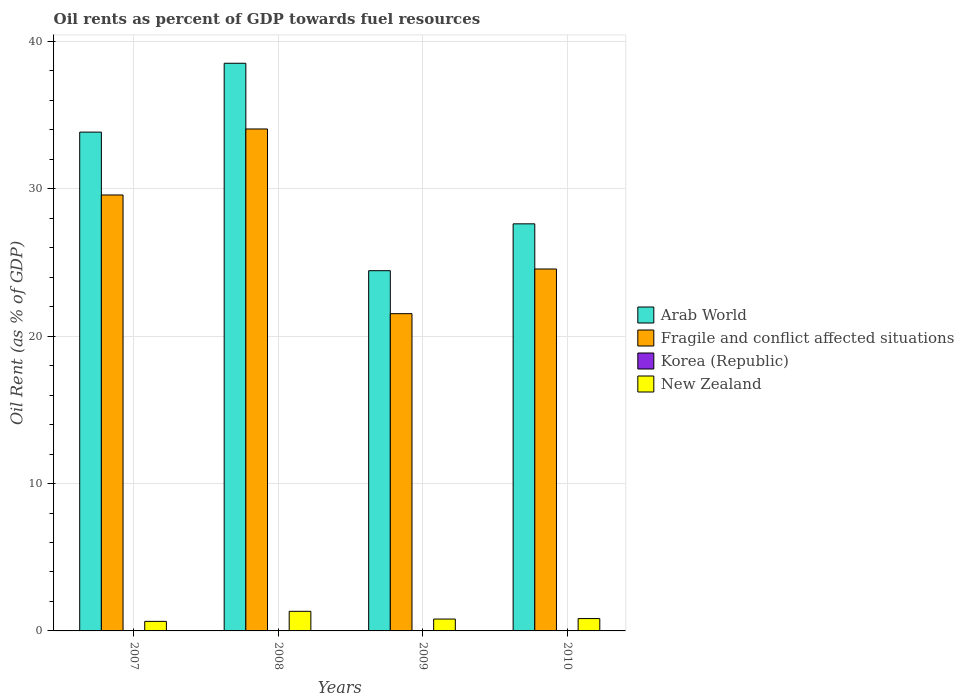How many different coloured bars are there?
Ensure brevity in your answer.  4. How many bars are there on the 1st tick from the left?
Offer a very short reply. 4. What is the label of the 1st group of bars from the left?
Ensure brevity in your answer.  2007. What is the oil rent in Korea (Republic) in 2009?
Give a very brief answer. 0. Across all years, what is the maximum oil rent in New Zealand?
Make the answer very short. 1.33. Across all years, what is the minimum oil rent in Arab World?
Keep it short and to the point. 24.44. In which year was the oil rent in Korea (Republic) maximum?
Offer a terse response. 2010. In which year was the oil rent in New Zealand minimum?
Make the answer very short. 2007. What is the total oil rent in Arab World in the graph?
Make the answer very short. 124.43. What is the difference between the oil rent in Arab World in 2008 and that in 2009?
Offer a terse response. 14.08. What is the difference between the oil rent in Korea (Republic) in 2008 and the oil rent in New Zealand in 2010?
Keep it short and to the point. -0.84. What is the average oil rent in Korea (Republic) per year?
Provide a short and direct response. 0. In the year 2009, what is the difference between the oil rent in Korea (Republic) and oil rent in New Zealand?
Ensure brevity in your answer.  -0.8. In how many years, is the oil rent in Korea (Republic) greater than 20 %?
Provide a succinct answer. 0. What is the ratio of the oil rent in Fragile and conflict affected situations in 2008 to that in 2010?
Provide a succinct answer. 1.39. What is the difference between the highest and the second highest oil rent in New Zealand?
Keep it short and to the point. 0.49. What is the difference between the highest and the lowest oil rent in Arab World?
Offer a very short reply. 14.08. Is the sum of the oil rent in Arab World in 2007 and 2009 greater than the maximum oil rent in New Zealand across all years?
Your answer should be very brief. Yes. Is it the case that in every year, the sum of the oil rent in Arab World and oil rent in Fragile and conflict affected situations is greater than the sum of oil rent in New Zealand and oil rent in Korea (Republic)?
Give a very brief answer. Yes. What does the 1st bar from the left in 2010 represents?
Your answer should be very brief. Arab World. What does the 1st bar from the right in 2009 represents?
Give a very brief answer. New Zealand. Is it the case that in every year, the sum of the oil rent in Korea (Republic) and oil rent in Arab World is greater than the oil rent in Fragile and conflict affected situations?
Provide a short and direct response. Yes. How many bars are there?
Give a very brief answer. 16. What is the difference between two consecutive major ticks on the Y-axis?
Provide a succinct answer. 10. Are the values on the major ticks of Y-axis written in scientific E-notation?
Provide a succinct answer. No. Does the graph contain any zero values?
Make the answer very short. No. Does the graph contain grids?
Provide a succinct answer. Yes. Where does the legend appear in the graph?
Your answer should be very brief. Center right. How are the legend labels stacked?
Give a very brief answer. Vertical. What is the title of the graph?
Offer a terse response. Oil rents as percent of GDP towards fuel resources. What is the label or title of the Y-axis?
Offer a very short reply. Oil Rent (as % of GDP). What is the Oil Rent (as % of GDP) in Arab World in 2007?
Give a very brief answer. 33.85. What is the Oil Rent (as % of GDP) of Fragile and conflict affected situations in 2007?
Keep it short and to the point. 29.58. What is the Oil Rent (as % of GDP) in Korea (Republic) in 2007?
Your answer should be compact. 0. What is the Oil Rent (as % of GDP) in New Zealand in 2007?
Offer a terse response. 0.65. What is the Oil Rent (as % of GDP) of Arab World in 2008?
Provide a succinct answer. 38.52. What is the Oil Rent (as % of GDP) in Fragile and conflict affected situations in 2008?
Your answer should be compact. 34.06. What is the Oil Rent (as % of GDP) in Korea (Republic) in 2008?
Offer a very short reply. 0. What is the Oil Rent (as % of GDP) in New Zealand in 2008?
Keep it short and to the point. 1.33. What is the Oil Rent (as % of GDP) in Arab World in 2009?
Ensure brevity in your answer.  24.44. What is the Oil Rent (as % of GDP) in Fragile and conflict affected situations in 2009?
Your answer should be compact. 21.53. What is the Oil Rent (as % of GDP) of Korea (Republic) in 2009?
Provide a succinct answer. 0. What is the Oil Rent (as % of GDP) in New Zealand in 2009?
Ensure brevity in your answer.  0.81. What is the Oil Rent (as % of GDP) of Arab World in 2010?
Your answer should be very brief. 27.62. What is the Oil Rent (as % of GDP) of Fragile and conflict affected situations in 2010?
Provide a short and direct response. 24.56. What is the Oil Rent (as % of GDP) of Korea (Republic) in 2010?
Provide a short and direct response. 0. What is the Oil Rent (as % of GDP) of New Zealand in 2010?
Give a very brief answer. 0.84. Across all years, what is the maximum Oil Rent (as % of GDP) of Arab World?
Give a very brief answer. 38.52. Across all years, what is the maximum Oil Rent (as % of GDP) in Fragile and conflict affected situations?
Give a very brief answer. 34.06. Across all years, what is the maximum Oil Rent (as % of GDP) in Korea (Republic)?
Give a very brief answer. 0. Across all years, what is the maximum Oil Rent (as % of GDP) in New Zealand?
Provide a short and direct response. 1.33. Across all years, what is the minimum Oil Rent (as % of GDP) of Arab World?
Offer a very short reply. 24.44. Across all years, what is the minimum Oil Rent (as % of GDP) of Fragile and conflict affected situations?
Provide a succinct answer. 21.53. Across all years, what is the minimum Oil Rent (as % of GDP) in Korea (Republic)?
Offer a very short reply. 0. Across all years, what is the minimum Oil Rent (as % of GDP) in New Zealand?
Provide a succinct answer. 0.65. What is the total Oil Rent (as % of GDP) in Arab World in the graph?
Your answer should be very brief. 124.43. What is the total Oil Rent (as % of GDP) in Fragile and conflict affected situations in the graph?
Your answer should be very brief. 109.73. What is the total Oil Rent (as % of GDP) of Korea (Republic) in the graph?
Provide a short and direct response. 0.01. What is the total Oil Rent (as % of GDP) in New Zealand in the graph?
Give a very brief answer. 3.62. What is the difference between the Oil Rent (as % of GDP) in Arab World in 2007 and that in 2008?
Provide a succinct answer. -4.67. What is the difference between the Oil Rent (as % of GDP) of Fragile and conflict affected situations in 2007 and that in 2008?
Provide a succinct answer. -4.48. What is the difference between the Oil Rent (as % of GDP) in Korea (Republic) in 2007 and that in 2008?
Your response must be concise. -0. What is the difference between the Oil Rent (as % of GDP) of New Zealand in 2007 and that in 2008?
Provide a succinct answer. -0.68. What is the difference between the Oil Rent (as % of GDP) of Arab World in 2007 and that in 2009?
Ensure brevity in your answer.  9.4. What is the difference between the Oil Rent (as % of GDP) of Fragile and conflict affected situations in 2007 and that in 2009?
Provide a short and direct response. 8.05. What is the difference between the Oil Rent (as % of GDP) in Korea (Republic) in 2007 and that in 2009?
Your answer should be compact. -0. What is the difference between the Oil Rent (as % of GDP) of New Zealand in 2007 and that in 2009?
Keep it short and to the point. -0.16. What is the difference between the Oil Rent (as % of GDP) in Arab World in 2007 and that in 2010?
Make the answer very short. 6.22. What is the difference between the Oil Rent (as % of GDP) in Fragile and conflict affected situations in 2007 and that in 2010?
Make the answer very short. 5.02. What is the difference between the Oil Rent (as % of GDP) in Korea (Republic) in 2007 and that in 2010?
Your answer should be compact. -0. What is the difference between the Oil Rent (as % of GDP) of New Zealand in 2007 and that in 2010?
Offer a terse response. -0.19. What is the difference between the Oil Rent (as % of GDP) in Arab World in 2008 and that in 2009?
Offer a very short reply. 14.08. What is the difference between the Oil Rent (as % of GDP) in Fragile and conflict affected situations in 2008 and that in 2009?
Keep it short and to the point. 12.53. What is the difference between the Oil Rent (as % of GDP) in Korea (Republic) in 2008 and that in 2009?
Provide a succinct answer. -0. What is the difference between the Oil Rent (as % of GDP) of New Zealand in 2008 and that in 2009?
Give a very brief answer. 0.52. What is the difference between the Oil Rent (as % of GDP) in Arab World in 2008 and that in 2010?
Give a very brief answer. 10.9. What is the difference between the Oil Rent (as % of GDP) in Fragile and conflict affected situations in 2008 and that in 2010?
Make the answer very short. 9.5. What is the difference between the Oil Rent (as % of GDP) in Korea (Republic) in 2008 and that in 2010?
Your response must be concise. -0. What is the difference between the Oil Rent (as % of GDP) of New Zealand in 2008 and that in 2010?
Your answer should be very brief. 0.49. What is the difference between the Oil Rent (as % of GDP) in Arab World in 2009 and that in 2010?
Ensure brevity in your answer.  -3.18. What is the difference between the Oil Rent (as % of GDP) of Fragile and conflict affected situations in 2009 and that in 2010?
Your response must be concise. -3.03. What is the difference between the Oil Rent (as % of GDP) of Korea (Republic) in 2009 and that in 2010?
Your answer should be very brief. -0. What is the difference between the Oil Rent (as % of GDP) in New Zealand in 2009 and that in 2010?
Provide a short and direct response. -0.03. What is the difference between the Oil Rent (as % of GDP) in Arab World in 2007 and the Oil Rent (as % of GDP) in Fragile and conflict affected situations in 2008?
Keep it short and to the point. -0.21. What is the difference between the Oil Rent (as % of GDP) in Arab World in 2007 and the Oil Rent (as % of GDP) in Korea (Republic) in 2008?
Give a very brief answer. 33.85. What is the difference between the Oil Rent (as % of GDP) in Arab World in 2007 and the Oil Rent (as % of GDP) in New Zealand in 2008?
Provide a short and direct response. 32.52. What is the difference between the Oil Rent (as % of GDP) of Fragile and conflict affected situations in 2007 and the Oil Rent (as % of GDP) of Korea (Republic) in 2008?
Provide a short and direct response. 29.58. What is the difference between the Oil Rent (as % of GDP) of Fragile and conflict affected situations in 2007 and the Oil Rent (as % of GDP) of New Zealand in 2008?
Provide a succinct answer. 28.25. What is the difference between the Oil Rent (as % of GDP) of Korea (Republic) in 2007 and the Oil Rent (as % of GDP) of New Zealand in 2008?
Offer a terse response. -1.33. What is the difference between the Oil Rent (as % of GDP) of Arab World in 2007 and the Oil Rent (as % of GDP) of Fragile and conflict affected situations in 2009?
Make the answer very short. 12.32. What is the difference between the Oil Rent (as % of GDP) in Arab World in 2007 and the Oil Rent (as % of GDP) in Korea (Republic) in 2009?
Give a very brief answer. 33.85. What is the difference between the Oil Rent (as % of GDP) of Arab World in 2007 and the Oil Rent (as % of GDP) of New Zealand in 2009?
Offer a very short reply. 33.04. What is the difference between the Oil Rent (as % of GDP) in Fragile and conflict affected situations in 2007 and the Oil Rent (as % of GDP) in Korea (Republic) in 2009?
Make the answer very short. 29.58. What is the difference between the Oil Rent (as % of GDP) of Fragile and conflict affected situations in 2007 and the Oil Rent (as % of GDP) of New Zealand in 2009?
Your response must be concise. 28.78. What is the difference between the Oil Rent (as % of GDP) in Korea (Republic) in 2007 and the Oil Rent (as % of GDP) in New Zealand in 2009?
Give a very brief answer. -0.8. What is the difference between the Oil Rent (as % of GDP) in Arab World in 2007 and the Oil Rent (as % of GDP) in Fragile and conflict affected situations in 2010?
Keep it short and to the point. 9.29. What is the difference between the Oil Rent (as % of GDP) in Arab World in 2007 and the Oil Rent (as % of GDP) in Korea (Republic) in 2010?
Provide a succinct answer. 33.84. What is the difference between the Oil Rent (as % of GDP) of Arab World in 2007 and the Oil Rent (as % of GDP) of New Zealand in 2010?
Keep it short and to the point. 33.01. What is the difference between the Oil Rent (as % of GDP) of Fragile and conflict affected situations in 2007 and the Oil Rent (as % of GDP) of Korea (Republic) in 2010?
Provide a succinct answer. 29.58. What is the difference between the Oil Rent (as % of GDP) of Fragile and conflict affected situations in 2007 and the Oil Rent (as % of GDP) of New Zealand in 2010?
Keep it short and to the point. 28.74. What is the difference between the Oil Rent (as % of GDP) in Korea (Republic) in 2007 and the Oil Rent (as % of GDP) in New Zealand in 2010?
Make the answer very short. -0.84. What is the difference between the Oil Rent (as % of GDP) of Arab World in 2008 and the Oil Rent (as % of GDP) of Fragile and conflict affected situations in 2009?
Provide a short and direct response. 16.99. What is the difference between the Oil Rent (as % of GDP) in Arab World in 2008 and the Oil Rent (as % of GDP) in Korea (Republic) in 2009?
Offer a terse response. 38.52. What is the difference between the Oil Rent (as % of GDP) of Arab World in 2008 and the Oil Rent (as % of GDP) of New Zealand in 2009?
Your answer should be compact. 37.71. What is the difference between the Oil Rent (as % of GDP) of Fragile and conflict affected situations in 2008 and the Oil Rent (as % of GDP) of Korea (Republic) in 2009?
Your answer should be very brief. 34.06. What is the difference between the Oil Rent (as % of GDP) in Fragile and conflict affected situations in 2008 and the Oil Rent (as % of GDP) in New Zealand in 2009?
Your answer should be very brief. 33.26. What is the difference between the Oil Rent (as % of GDP) in Korea (Republic) in 2008 and the Oil Rent (as % of GDP) in New Zealand in 2009?
Offer a very short reply. -0.8. What is the difference between the Oil Rent (as % of GDP) in Arab World in 2008 and the Oil Rent (as % of GDP) in Fragile and conflict affected situations in 2010?
Ensure brevity in your answer.  13.96. What is the difference between the Oil Rent (as % of GDP) in Arab World in 2008 and the Oil Rent (as % of GDP) in Korea (Republic) in 2010?
Provide a succinct answer. 38.52. What is the difference between the Oil Rent (as % of GDP) of Arab World in 2008 and the Oil Rent (as % of GDP) of New Zealand in 2010?
Offer a terse response. 37.68. What is the difference between the Oil Rent (as % of GDP) of Fragile and conflict affected situations in 2008 and the Oil Rent (as % of GDP) of Korea (Republic) in 2010?
Your response must be concise. 34.06. What is the difference between the Oil Rent (as % of GDP) of Fragile and conflict affected situations in 2008 and the Oil Rent (as % of GDP) of New Zealand in 2010?
Keep it short and to the point. 33.22. What is the difference between the Oil Rent (as % of GDP) of Korea (Republic) in 2008 and the Oil Rent (as % of GDP) of New Zealand in 2010?
Ensure brevity in your answer.  -0.84. What is the difference between the Oil Rent (as % of GDP) of Arab World in 2009 and the Oil Rent (as % of GDP) of Fragile and conflict affected situations in 2010?
Make the answer very short. -0.12. What is the difference between the Oil Rent (as % of GDP) of Arab World in 2009 and the Oil Rent (as % of GDP) of Korea (Republic) in 2010?
Your answer should be very brief. 24.44. What is the difference between the Oil Rent (as % of GDP) of Arab World in 2009 and the Oil Rent (as % of GDP) of New Zealand in 2010?
Make the answer very short. 23.61. What is the difference between the Oil Rent (as % of GDP) of Fragile and conflict affected situations in 2009 and the Oil Rent (as % of GDP) of Korea (Republic) in 2010?
Ensure brevity in your answer.  21.53. What is the difference between the Oil Rent (as % of GDP) of Fragile and conflict affected situations in 2009 and the Oil Rent (as % of GDP) of New Zealand in 2010?
Provide a short and direct response. 20.69. What is the difference between the Oil Rent (as % of GDP) in Korea (Republic) in 2009 and the Oil Rent (as % of GDP) in New Zealand in 2010?
Ensure brevity in your answer.  -0.84. What is the average Oil Rent (as % of GDP) of Arab World per year?
Offer a very short reply. 31.11. What is the average Oil Rent (as % of GDP) in Fragile and conflict affected situations per year?
Your response must be concise. 27.43. What is the average Oil Rent (as % of GDP) of Korea (Republic) per year?
Your answer should be compact. 0. What is the average Oil Rent (as % of GDP) of New Zealand per year?
Provide a succinct answer. 0.91. In the year 2007, what is the difference between the Oil Rent (as % of GDP) in Arab World and Oil Rent (as % of GDP) in Fragile and conflict affected situations?
Offer a very short reply. 4.27. In the year 2007, what is the difference between the Oil Rent (as % of GDP) in Arab World and Oil Rent (as % of GDP) in Korea (Republic)?
Offer a terse response. 33.85. In the year 2007, what is the difference between the Oil Rent (as % of GDP) of Arab World and Oil Rent (as % of GDP) of New Zealand?
Your response must be concise. 33.2. In the year 2007, what is the difference between the Oil Rent (as % of GDP) in Fragile and conflict affected situations and Oil Rent (as % of GDP) in Korea (Republic)?
Your answer should be compact. 29.58. In the year 2007, what is the difference between the Oil Rent (as % of GDP) in Fragile and conflict affected situations and Oil Rent (as % of GDP) in New Zealand?
Provide a succinct answer. 28.93. In the year 2007, what is the difference between the Oil Rent (as % of GDP) of Korea (Republic) and Oil Rent (as % of GDP) of New Zealand?
Your answer should be very brief. -0.65. In the year 2008, what is the difference between the Oil Rent (as % of GDP) of Arab World and Oil Rent (as % of GDP) of Fragile and conflict affected situations?
Your answer should be very brief. 4.46. In the year 2008, what is the difference between the Oil Rent (as % of GDP) in Arab World and Oil Rent (as % of GDP) in Korea (Republic)?
Offer a terse response. 38.52. In the year 2008, what is the difference between the Oil Rent (as % of GDP) in Arab World and Oil Rent (as % of GDP) in New Zealand?
Keep it short and to the point. 37.19. In the year 2008, what is the difference between the Oil Rent (as % of GDP) of Fragile and conflict affected situations and Oil Rent (as % of GDP) of Korea (Republic)?
Ensure brevity in your answer.  34.06. In the year 2008, what is the difference between the Oil Rent (as % of GDP) in Fragile and conflict affected situations and Oil Rent (as % of GDP) in New Zealand?
Make the answer very short. 32.73. In the year 2008, what is the difference between the Oil Rent (as % of GDP) of Korea (Republic) and Oil Rent (as % of GDP) of New Zealand?
Your answer should be very brief. -1.33. In the year 2009, what is the difference between the Oil Rent (as % of GDP) in Arab World and Oil Rent (as % of GDP) in Fragile and conflict affected situations?
Your answer should be very brief. 2.92. In the year 2009, what is the difference between the Oil Rent (as % of GDP) in Arab World and Oil Rent (as % of GDP) in Korea (Republic)?
Make the answer very short. 24.44. In the year 2009, what is the difference between the Oil Rent (as % of GDP) of Arab World and Oil Rent (as % of GDP) of New Zealand?
Keep it short and to the point. 23.64. In the year 2009, what is the difference between the Oil Rent (as % of GDP) of Fragile and conflict affected situations and Oil Rent (as % of GDP) of Korea (Republic)?
Provide a succinct answer. 21.53. In the year 2009, what is the difference between the Oil Rent (as % of GDP) in Fragile and conflict affected situations and Oil Rent (as % of GDP) in New Zealand?
Make the answer very short. 20.72. In the year 2009, what is the difference between the Oil Rent (as % of GDP) of Korea (Republic) and Oil Rent (as % of GDP) of New Zealand?
Keep it short and to the point. -0.8. In the year 2010, what is the difference between the Oil Rent (as % of GDP) of Arab World and Oil Rent (as % of GDP) of Fragile and conflict affected situations?
Give a very brief answer. 3.06. In the year 2010, what is the difference between the Oil Rent (as % of GDP) of Arab World and Oil Rent (as % of GDP) of Korea (Republic)?
Your answer should be compact. 27.62. In the year 2010, what is the difference between the Oil Rent (as % of GDP) in Arab World and Oil Rent (as % of GDP) in New Zealand?
Provide a short and direct response. 26.79. In the year 2010, what is the difference between the Oil Rent (as % of GDP) of Fragile and conflict affected situations and Oil Rent (as % of GDP) of Korea (Republic)?
Give a very brief answer. 24.56. In the year 2010, what is the difference between the Oil Rent (as % of GDP) of Fragile and conflict affected situations and Oil Rent (as % of GDP) of New Zealand?
Ensure brevity in your answer.  23.72. In the year 2010, what is the difference between the Oil Rent (as % of GDP) in Korea (Republic) and Oil Rent (as % of GDP) in New Zealand?
Your answer should be compact. -0.84. What is the ratio of the Oil Rent (as % of GDP) of Arab World in 2007 to that in 2008?
Keep it short and to the point. 0.88. What is the ratio of the Oil Rent (as % of GDP) of Fragile and conflict affected situations in 2007 to that in 2008?
Your response must be concise. 0.87. What is the ratio of the Oil Rent (as % of GDP) in Korea (Republic) in 2007 to that in 2008?
Provide a succinct answer. 0.96. What is the ratio of the Oil Rent (as % of GDP) in New Zealand in 2007 to that in 2008?
Provide a succinct answer. 0.49. What is the ratio of the Oil Rent (as % of GDP) in Arab World in 2007 to that in 2009?
Your answer should be very brief. 1.38. What is the ratio of the Oil Rent (as % of GDP) of Fragile and conflict affected situations in 2007 to that in 2009?
Your answer should be compact. 1.37. What is the ratio of the Oil Rent (as % of GDP) in Korea (Republic) in 2007 to that in 2009?
Offer a terse response. 0.74. What is the ratio of the Oil Rent (as % of GDP) in New Zealand in 2007 to that in 2009?
Your answer should be very brief. 0.8. What is the ratio of the Oil Rent (as % of GDP) in Arab World in 2007 to that in 2010?
Ensure brevity in your answer.  1.23. What is the ratio of the Oil Rent (as % of GDP) in Fragile and conflict affected situations in 2007 to that in 2010?
Your answer should be very brief. 1.2. What is the ratio of the Oil Rent (as % of GDP) in Korea (Republic) in 2007 to that in 2010?
Your answer should be compact. 0.54. What is the ratio of the Oil Rent (as % of GDP) in New Zealand in 2007 to that in 2010?
Your answer should be compact. 0.77. What is the ratio of the Oil Rent (as % of GDP) in Arab World in 2008 to that in 2009?
Ensure brevity in your answer.  1.58. What is the ratio of the Oil Rent (as % of GDP) in Fragile and conflict affected situations in 2008 to that in 2009?
Your answer should be compact. 1.58. What is the ratio of the Oil Rent (as % of GDP) of Korea (Republic) in 2008 to that in 2009?
Make the answer very short. 0.77. What is the ratio of the Oil Rent (as % of GDP) in New Zealand in 2008 to that in 2009?
Offer a terse response. 1.65. What is the ratio of the Oil Rent (as % of GDP) in Arab World in 2008 to that in 2010?
Provide a short and direct response. 1.39. What is the ratio of the Oil Rent (as % of GDP) of Fragile and conflict affected situations in 2008 to that in 2010?
Offer a terse response. 1.39. What is the ratio of the Oil Rent (as % of GDP) in Korea (Republic) in 2008 to that in 2010?
Your answer should be compact. 0.56. What is the ratio of the Oil Rent (as % of GDP) in New Zealand in 2008 to that in 2010?
Provide a succinct answer. 1.59. What is the ratio of the Oil Rent (as % of GDP) in Arab World in 2009 to that in 2010?
Provide a succinct answer. 0.88. What is the ratio of the Oil Rent (as % of GDP) in Fragile and conflict affected situations in 2009 to that in 2010?
Provide a succinct answer. 0.88. What is the ratio of the Oil Rent (as % of GDP) of Korea (Republic) in 2009 to that in 2010?
Make the answer very short. 0.73. What is the ratio of the Oil Rent (as % of GDP) in New Zealand in 2009 to that in 2010?
Your response must be concise. 0.96. What is the difference between the highest and the second highest Oil Rent (as % of GDP) in Arab World?
Provide a short and direct response. 4.67. What is the difference between the highest and the second highest Oil Rent (as % of GDP) in Fragile and conflict affected situations?
Make the answer very short. 4.48. What is the difference between the highest and the second highest Oil Rent (as % of GDP) of Korea (Republic)?
Provide a short and direct response. 0. What is the difference between the highest and the second highest Oil Rent (as % of GDP) in New Zealand?
Your answer should be very brief. 0.49. What is the difference between the highest and the lowest Oil Rent (as % of GDP) of Arab World?
Provide a short and direct response. 14.08. What is the difference between the highest and the lowest Oil Rent (as % of GDP) in Fragile and conflict affected situations?
Provide a succinct answer. 12.53. What is the difference between the highest and the lowest Oil Rent (as % of GDP) in Korea (Republic)?
Make the answer very short. 0. What is the difference between the highest and the lowest Oil Rent (as % of GDP) in New Zealand?
Offer a very short reply. 0.68. 